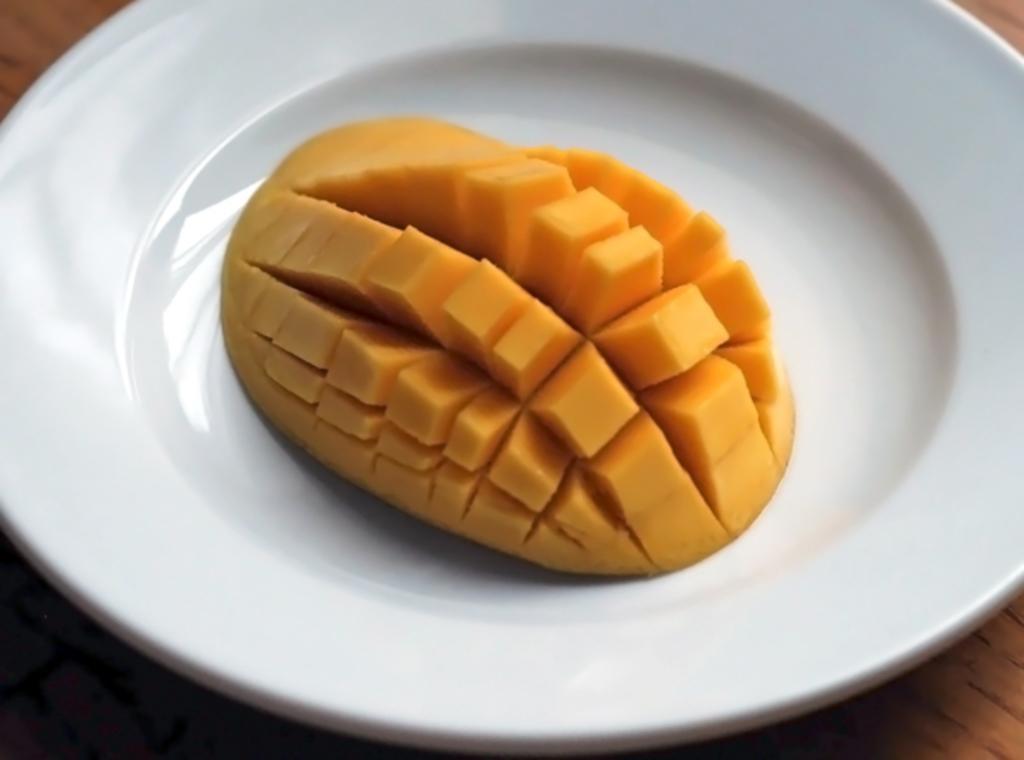How would you summarize this image in a sentence or two? In the center of the image we can see mango in plate placed on the table. 